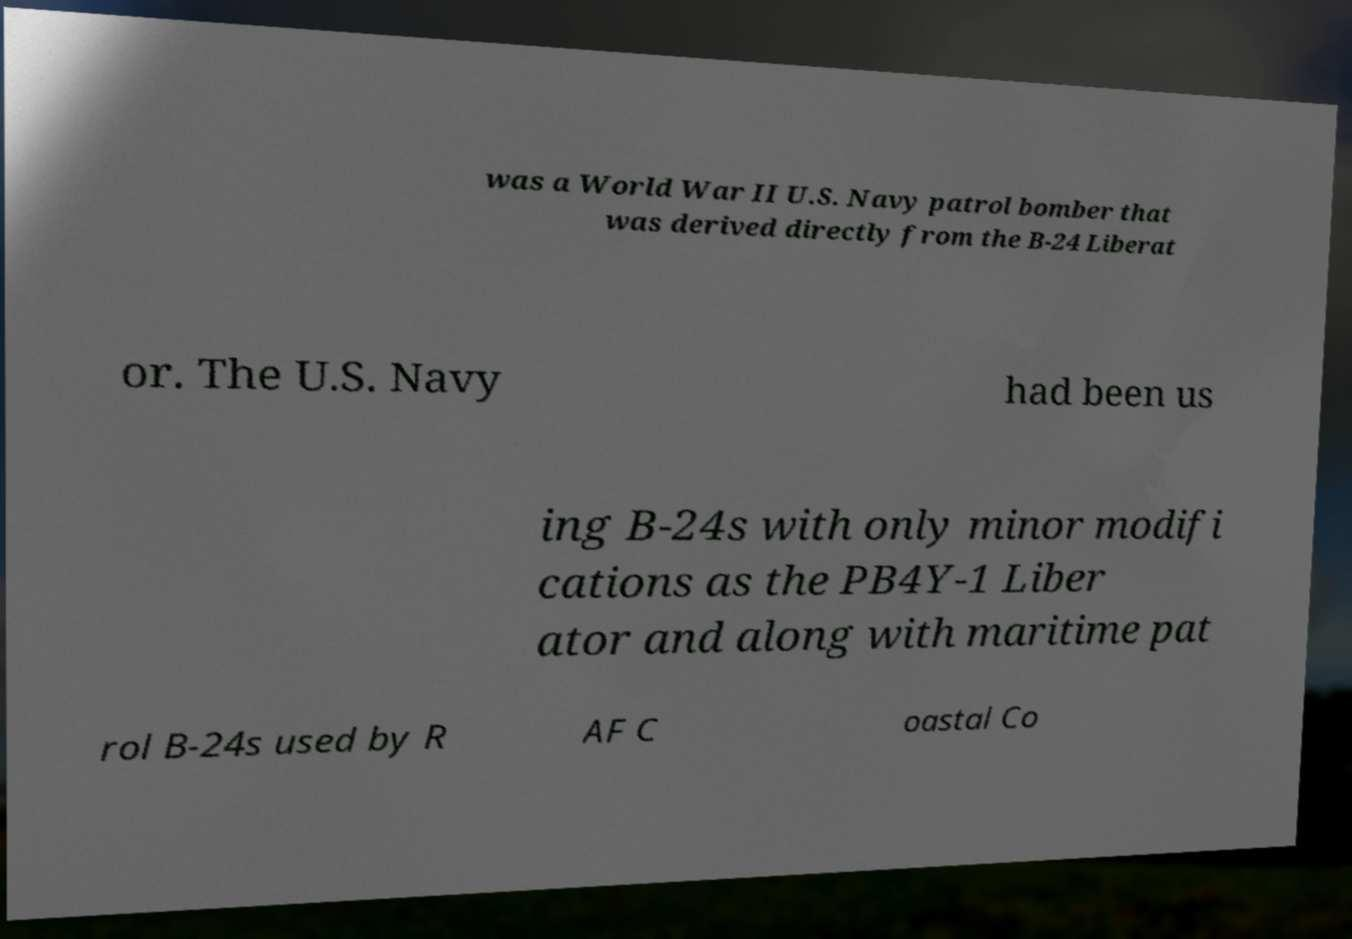I need the written content from this picture converted into text. Can you do that? was a World War II U.S. Navy patrol bomber that was derived directly from the B-24 Liberat or. The U.S. Navy had been us ing B-24s with only minor modifi cations as the PB4Y-1 Liber ator and along with maritime pat rol B-24s used by R AF C oastal Co 